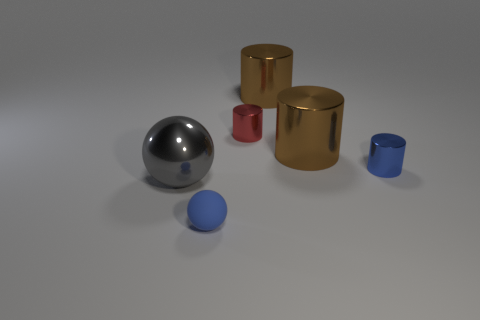Subtract all blue shiny cylinders. How many cylinders are left? 3 Subtract all gray spheres. How many spheres are left? 1 Add 1 big gray objects. How many objects exist? 7 Subtract all spheres. How many objects are left? 4 Subtract 2 spheres. How many spheres are left? 0 Subtract all purple balls. Subtract all cyan cubes. How many balls are left? 2 Subtract all gray blocks. How many gray cylinders are left? 0 Subtract all tiny brown rubber blocks. Subtract all tiny red things. How many objects are left? 5 Add 2 red cylinders. How many red cylinders are left? 3 Add 4 cylinders. How many cylinders exist? 8 